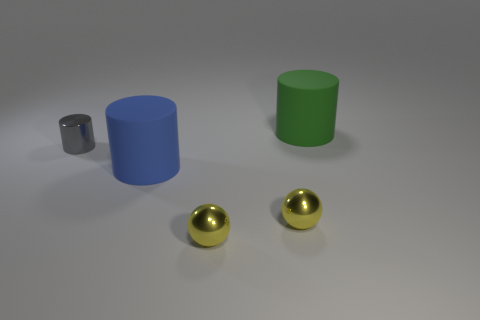Add 4 gray shiny cylinders. How many objects exist? 9 Subtract all cylinders. How many objects are left? 2 Subtract all metallic cylinders. Subtract all small yellow objects. How many objects are left? 2 Add 2 tiny shiny spheres. How many tiny shiny spheres are left? 4 Add 5 large blue matte objects. How many large blue matte objects exist? 6 Subtract 0 yellow blocks. How many objects are left? 5 